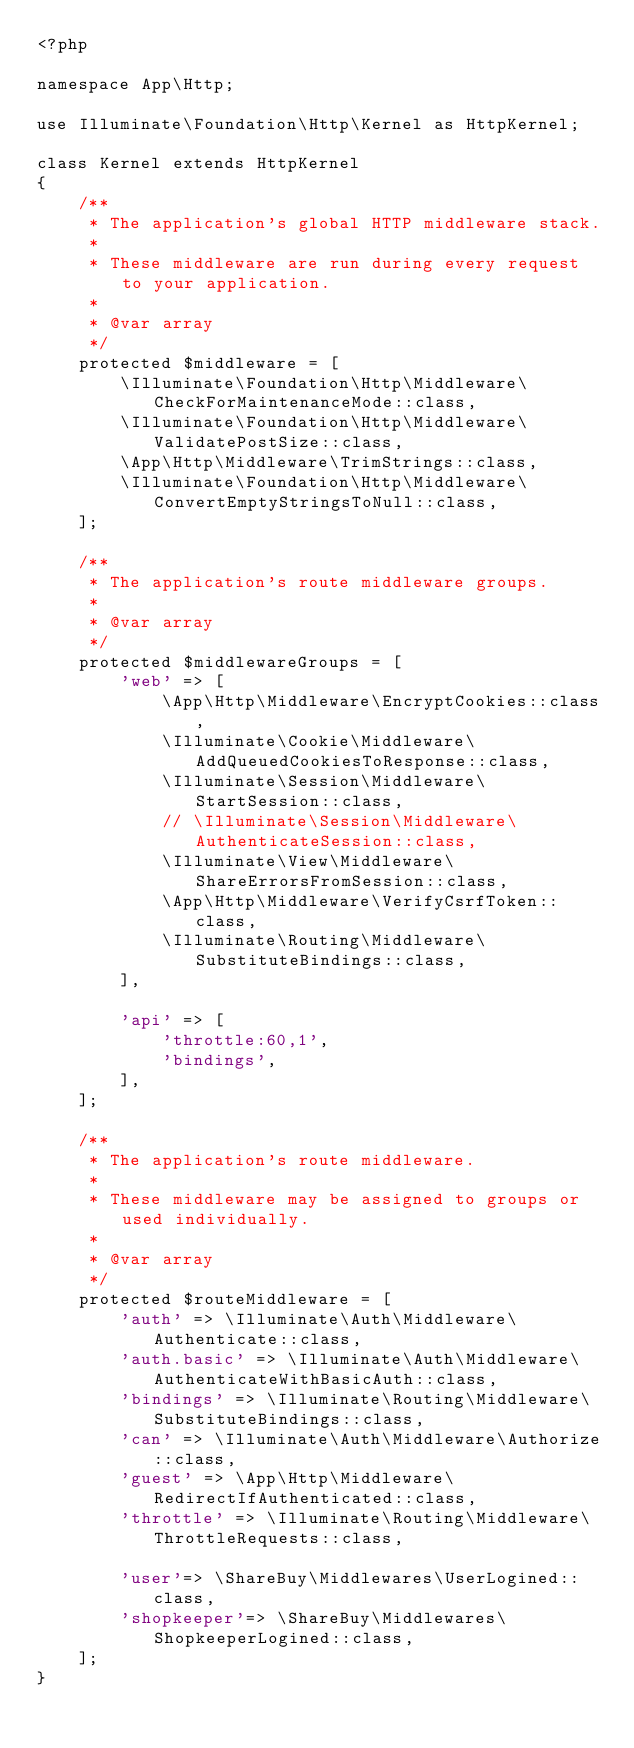<code> <loc_0><loc_0><loc_500><loc_500><_PHP_><?php

namespace App\Http;

use Illuminate\Foundation\Http\Kernel as HttpKernel;

class Kernel extends HttpKernel
{
    /**
     * The application's global HTTP middleware stack.
     *
     * These middleware are run during every request to your application.
     *
     * @var array
     */
    protected $middleware = [
        \Illuminate\Foundation\Http\Middleware\CheckForMaintenanceMode::class,
        \Illuminate\Foundation\Http\Middleware\ValidatePostSize::class,
        \App\Http\Middleware\TrimStrings::class,
        \Illuminate\Foundation\Http\Middleware\ConvertEmptyStringsToNull::class,
    ];

    /**
     * The application's route middleware groups.
     *
     * @var array
     */
    protected $middlewareGroups = [
        'web' => [
            \App\Http\Middleware\EncryptCookies::class,
            \Illuminate\Cookie\Middleware\AddQueuedCookiesToResponse::class,
            \Illuminate\Session\Middleware\StartSession::class,
            // \Illuminate\Session\Middleware\AuthenticateSession::class,
            \Illuminate\View\Middleware\ShareErrorsFromSession::class,
            \App\Http\Middleware\VerifyCsrfToken::class,
            \Illuminate\Routing\Middleware\SubstituteBindings::class,
        ],

        'api' => [
            'throttle:60,1',
            'bindings',
        ],
    ];

    /**
     * The application's route middleware.
     *
     * These middleware may be assigned to groups or used individually.
     *
     * @var array
     */
    protected $routeMiddleware = [
        'auth' => \Illuminate\Auth\Middleware\Authenticate::class,
        'auth.basic' => \Illuminate\Auth\Middleware\AuthenticateWithBasicAuth::class,
        'bindings' => \Illuminate\Routing\Middleware\SubstituteBindings::class,
        'can' => \Illuminate\Auth\Middleware\Authorize::class,
        'guest' => \App\Http\Middleware\RedirectIfAuthenticated::class,
        'throttle' => \Illuminate\Routing\Middleware\ThrottleRequests::class,

        'user'=> \ShareBuy\Middlewares\UserLogined::class,
        'shopkeeper'=> \ShareBuy\Middlewares\ShopkeeperLogined::class,
    ];
}
</code> 